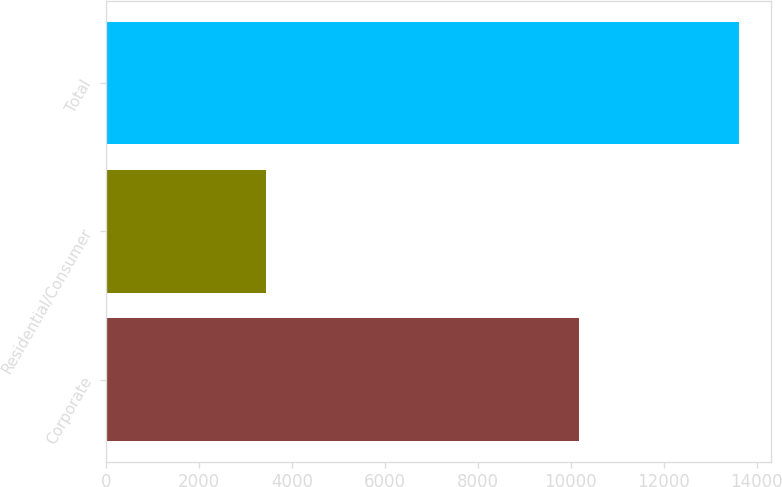<chart> <loc_0><loc_0><loc_500><loc_500><bar_chart><fcel>Corporate<fcel>Residential/Consumer<fcel>Total<nl><fcel>10169<fcel>3447<fcel>13616<nl></chart> 